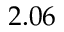Convert formula to latex. <formula><loc_0><loc_0><loc_500><loc_500>2 . 0 6</formula> 